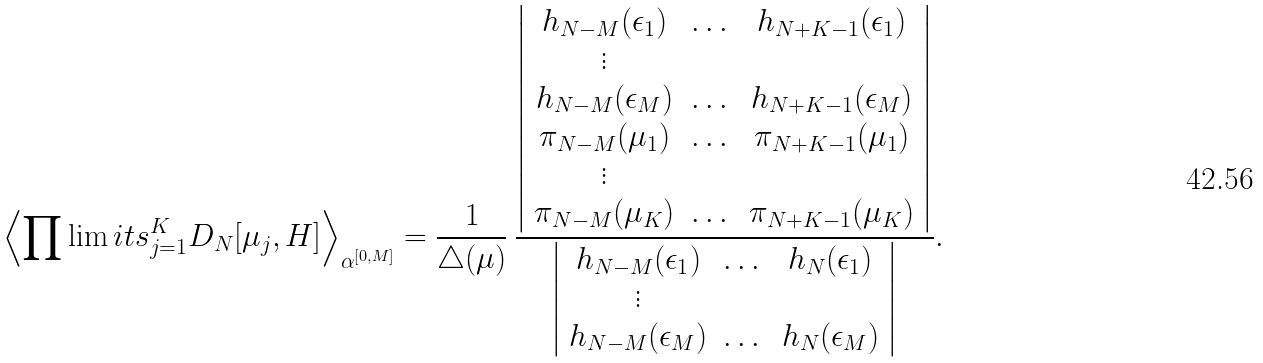Convert formula to latex. <formula><loc_0><loc_0><loc_500><loc_500>\left \langle \prod \lim i t s _ { j = 1 } ^ { K } D _ { N } [ \mu _ { j } , H ] \right \rangle _ { \alpha ^ { [ 0 , M ] } } = \frac { 1 } { \triangle ( \mu ) } \, \frac { \left | \begin{array} { c c c } h _ { N - M } ( \epsilon _ { 1 } ) & \dots & h _ { N + K - 1 } ( \epsilon _ { 1 } ) \\ \vdots & & \\ h _ { N - M } ( \epsilon _ { M } ) & \dots & h _ { N + K - 1 } ( \epsilon _ { M } ) \\ \pi _ { N - M } ( \mu _ { 1 } ) & \dots & \pi _ { N + K - 1 } ( \mu _ { 1 } ) \\ \vdots & & \\ \pi _ { N - M } ( \mu _ { K } ) & \dots & \pi _ { N + K - 1 } ( \mu _ { K } ) \end{array} \right | } { \left | \begin{array} { c c c } h _ { N - M } ( \epsilon _ { 1 } ) & \dots & h _ { N } ( \epsilon _ { 1 } ) \\ \vdots & & \\ h _ { N - M } ( \epsilon _ { M } ) & \dots & h _ { N } ( \epsilon _ { M } ) \end{array} \right | } .</formula> 